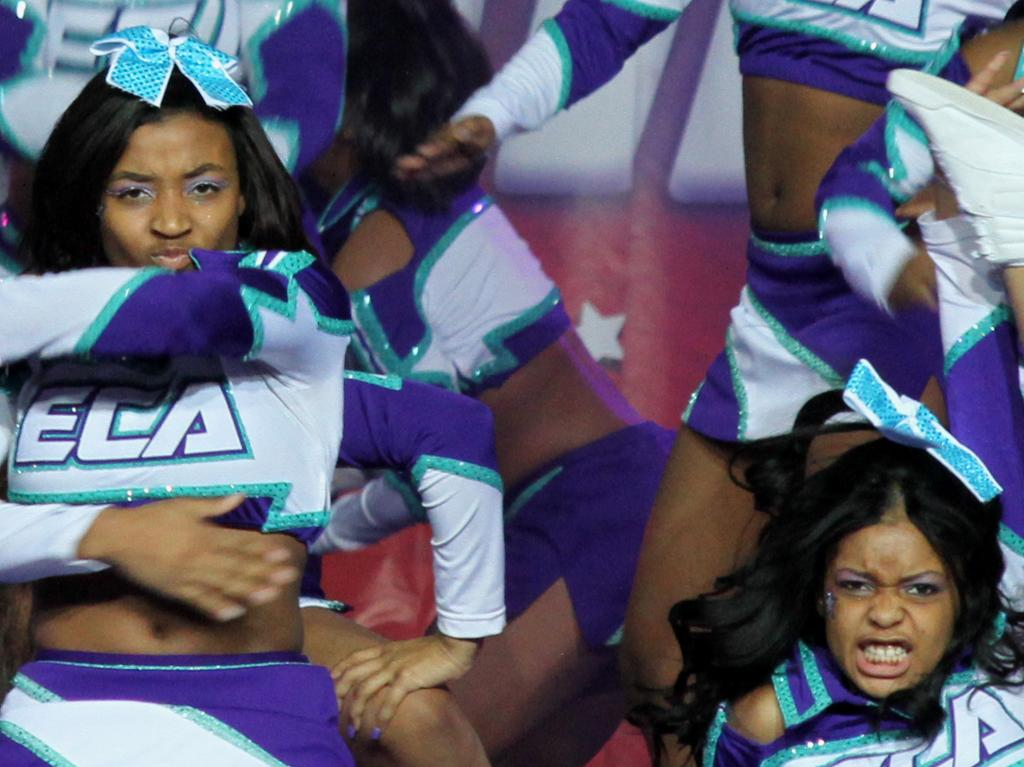<image>
Offer a succinct explanation of the picture presented. a shirt that has the letters ela on it 